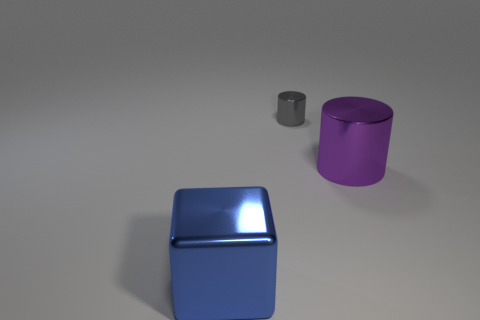Is the number of objects on the left side of the big shiny cube the same as the number of large purple cylinders?
Make the answer very short. No. What number of other big things have the same shape as the big purple metal object?
Make the answer very short. 0. Is the shape of the gray shiny object the same as the big purple metallic thing?
Provide a succinct answer. Yes. What number of things are things to the left of the big cylinder or metallic objects?
Provide a short and direct response. 3. What shape is the metal object that is in front of the large object to the right of the large shiny thing that is left of the tiny cylinder?
Ensure brevity in your answer.  Cube. There is a large blue object that is made of the same material as the purple object; what is its shape?
Offer a terse response. Cube. The gray object is what size?
Offer a very short reply. Small. Does the purple metal cylinder have the same size as the gray shiny cylinder?
Offer a terse response. No. What number of objects are big metallic things behind the blue metal cube or metal objects that are to the left of the large purple metal object?
Offer a very short reply. 3. There is a cylinder to the left of the large object that is to the right of the gray metal cylinder; how many big objects are on the right side of it?
Provide a succinct answer. 1. 